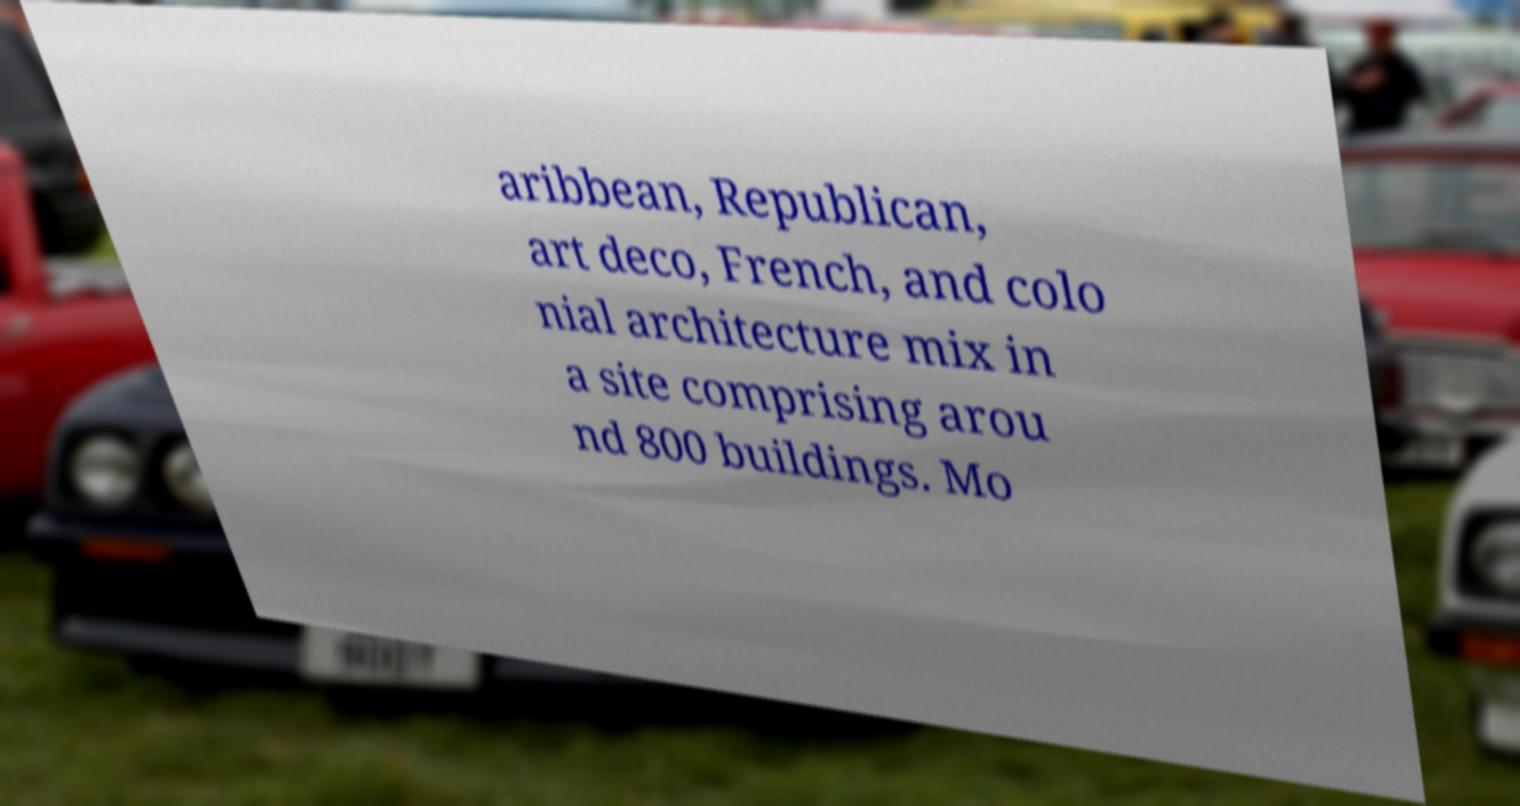Please identify and transcribe the text found in this image. aribbean, Republican, art deco, French, and colo nial architecture mix in a site comprising arou nd 800 buildings. Mo 